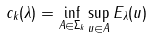Convert formula to latex. <formula><loc_0><loc_0><loc_500><loc_500>c _ { k } ( \lambda ) = \inf _ { A \in \Sigma _ { k } } \sup _ { u \in A } E _ { \lambda } ( u )</formula> 